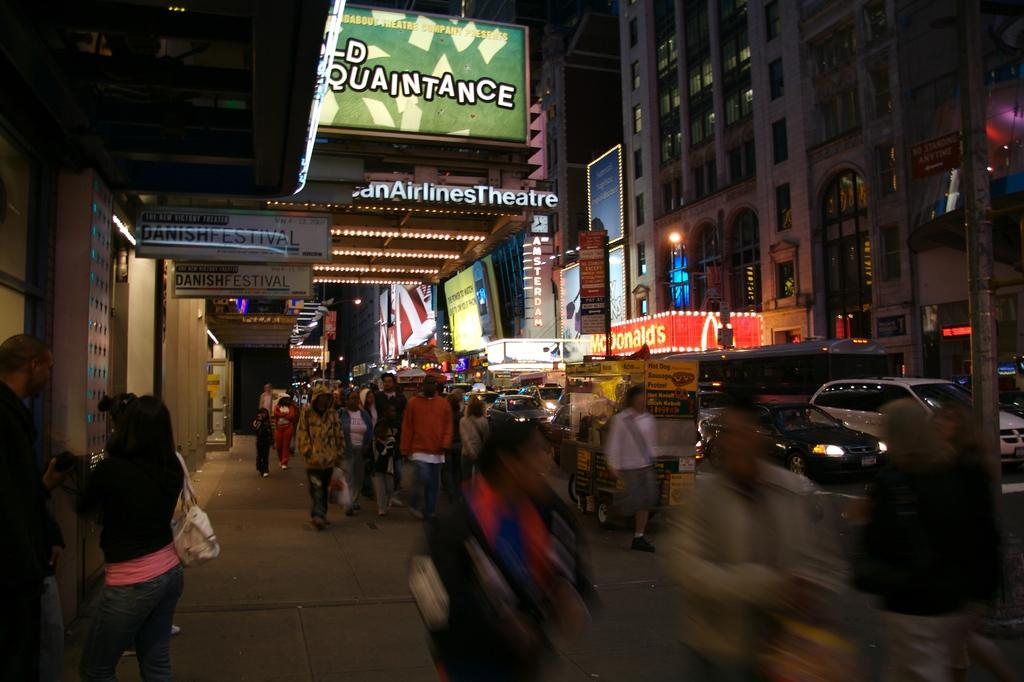What are the people in the image doing? The people in the image are walking on the footpath. What else can be seen on the road besides the people? There are vehicles on the road. What is visible on the right side of the image? There are buildings with windows and a pole on the right side of the image. What type of produce can be seen growing on the footpath? There is no produce visible on the footpath in the image. 